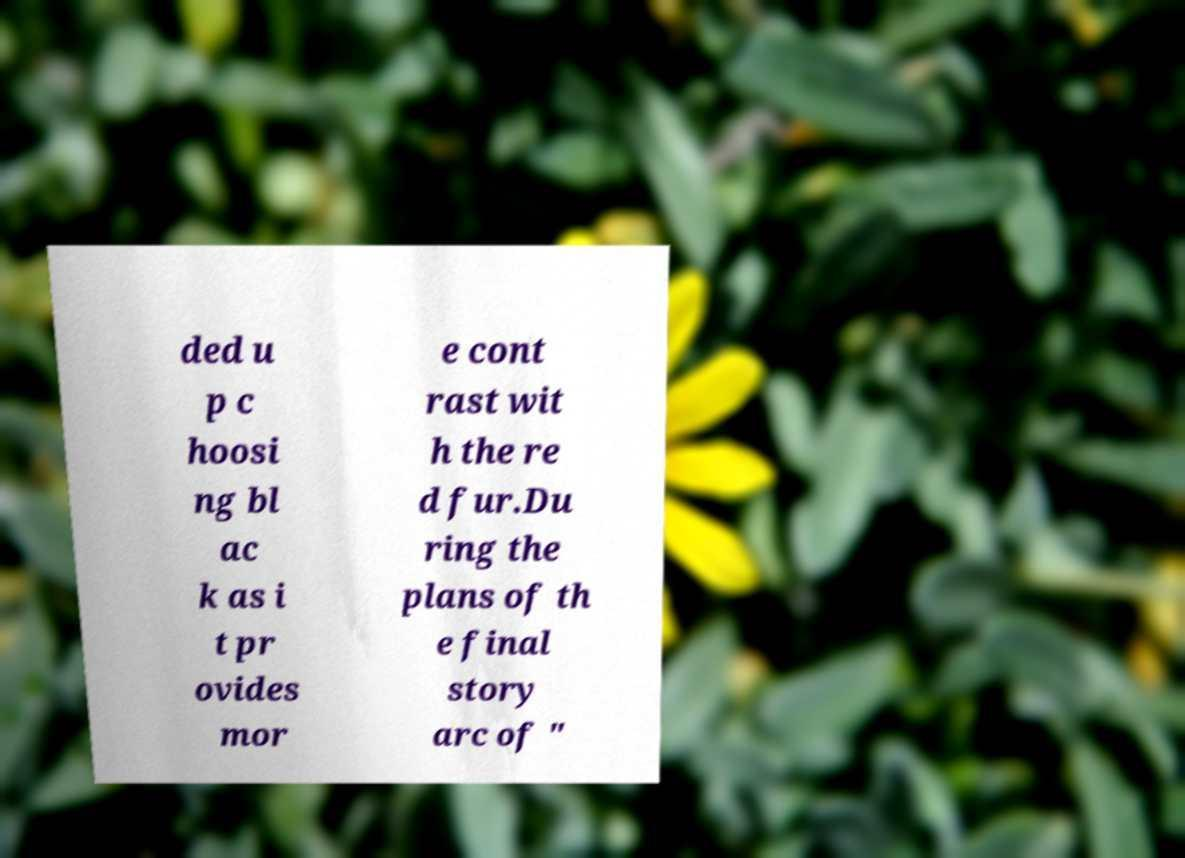Could you assist in decoding the text presented in this image and type it out clearly? ded u p c hoosi ng bl ac k as i t pr ovides mor e cont rast wit h the re d fur.Du ring the plans of th e final story arc of " 